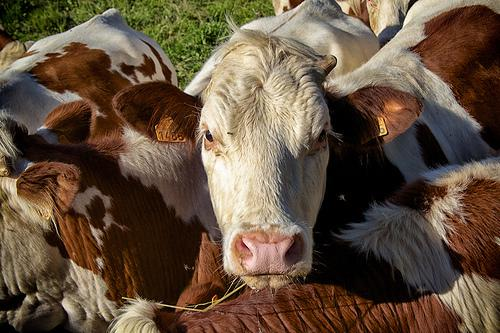Question: what is the cow eating?
Choices:
A. Grass.
B. Hay.
C. Silage.
D. Flowers.
Answer with the letter. Answer: A Question: what is in the picture?
Choices:
A. Goats.
B. A gaggle of geese.
C. A pride of lions.
D. Cows.
Answer with the letter. Answer: D Question: who tagged the cows?
Choices:
A. Farmer.
B. The paint ball players.
C. The park ranger.
D. The zoologist.
Answer with the letter. Answer: A Question: why is the cow looking ahead?
Choices:
A. The other cow.
B. Looking at photographer.
C. The goat.
D. The tractor.
Answer with the letter. Answer: B 